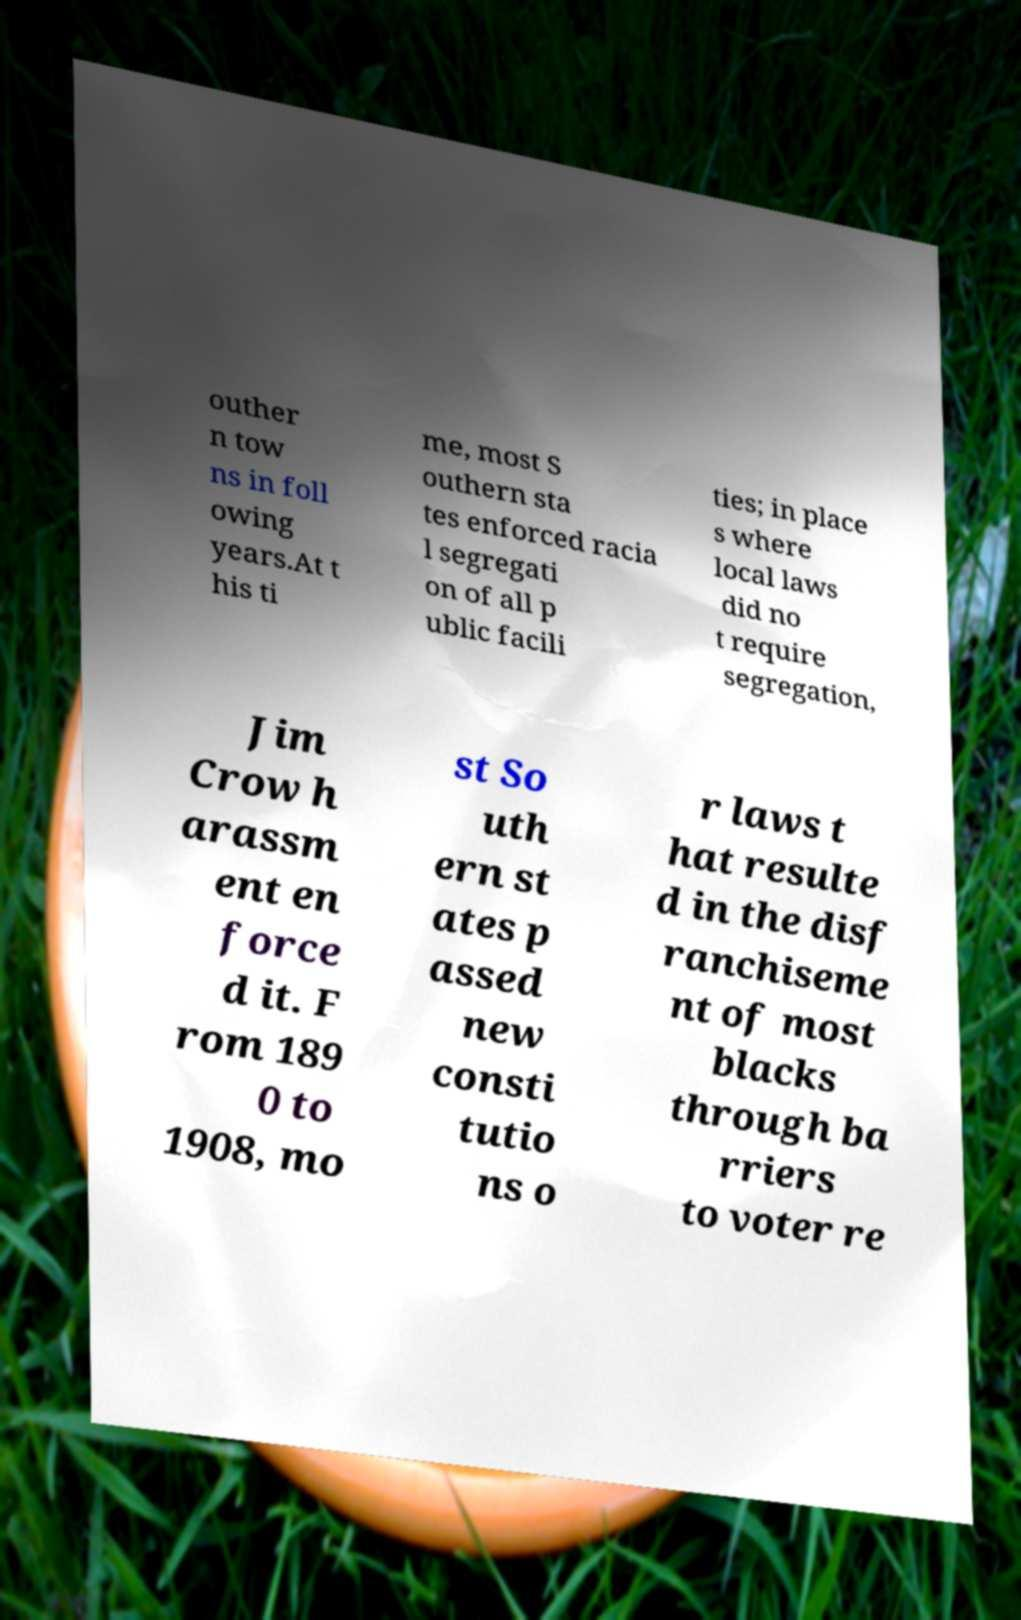Please read and relay the text visible in this image. What does it say? outher n tow ns in foll owing years.At t his ti me, most S outhern sta tes enforced racia l segregati on of all p ublic facili ties; in place s where local laws did no t require segregation, Jim Crow h arassm ent en force d it. F rom 189 0 to 1908, mo st So uth ern st ates p assed new consti tutio ns o r laws t hat resulte d in the disf ranchiseme nt of most blacks through ba rriers to voter re 